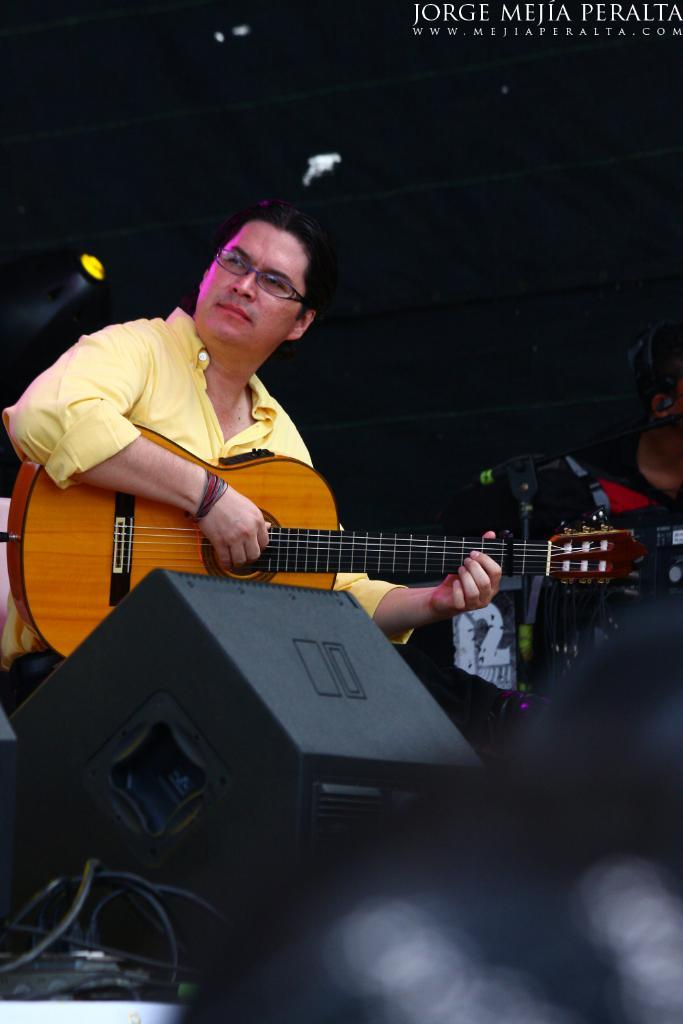What is the main subject of the image? There is a person in the image. What is the person holding in the image? The person is holding a guitar. What color is the shirt the person is wearing? The person is wearing a yellow shirt. What accessory is the person wearing in the image? The person is wearing spectacles. What type of army is visible in the image? There is no army present in the image; it features a person holding a guitar and wearing a yellow shirt and spectacles. How many rats can be seen in the image? There are no rats present in the image. 